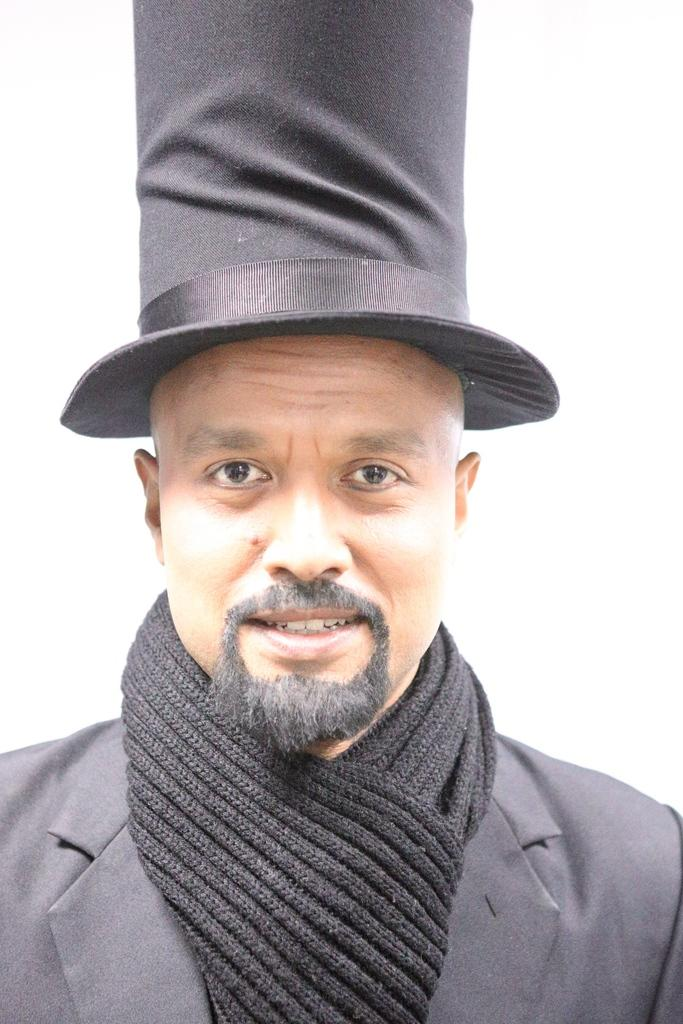Who is present in the image? There is a man in the image. What is the man wearing on his head? The man is wearing a hat. What can be seen behind the man in the image? The background of the image appears to be white. Can you see any boats or harbors in the image? No, there are no boats or harbors present in the image. 